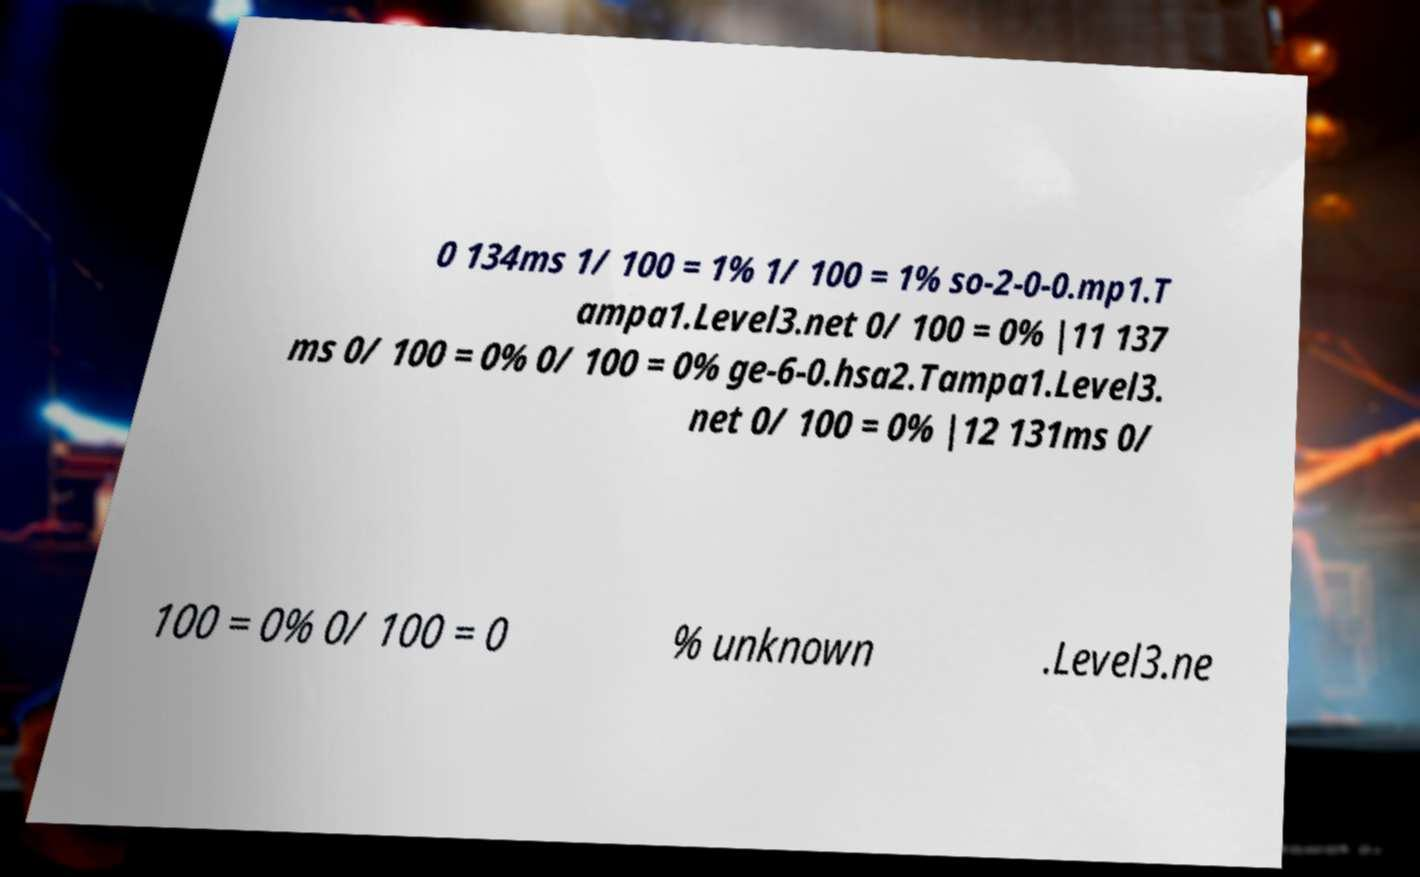Can you accurately transcribe the text from the provided image for me? 0 134ms 1/ 100 = 1% 1/ 100 = 1% so-2-0-0.mp1.T ampa1.Level3.net 0/ 100 = 0% |11 137 ms 0/ 100 = 0% 0/ 100 = 0% ge-6-0.hsa2.Tampa1.Level3. net 0/ 100 = 0% |12 131ms 0/ 100 = 0% 0/ 100 = 0 % unknown .Level3.ne 